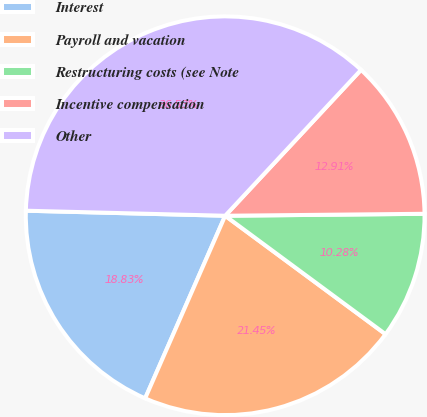Convert chart. <chart><loc_0><loc_0><loc_500><loc_500><pie_chart><fcel>Interest<fcel>Payroll and vacation<fcel>Restructuring costs (see Note<fcel>Incentive compensation<fcel>Other<nl><fcel>18.83%<fcel>21.45%<fcel>10.28%<fcel>12.91%<fcel>36.53%<nl></chart> 